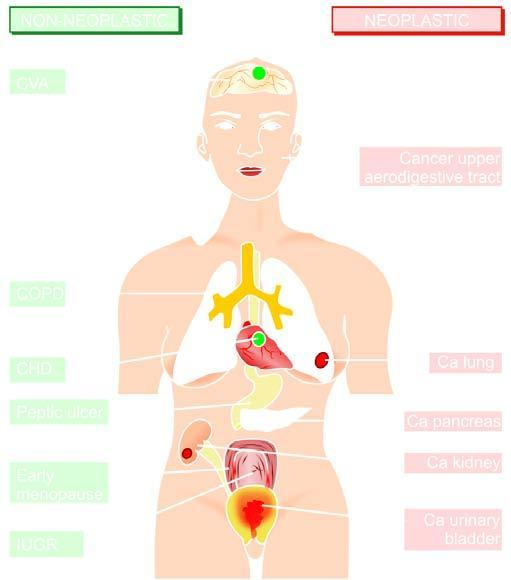what indicates non-neoplastic diseases associated with smoking?
Answer the question using a single word or phrase. Left side 